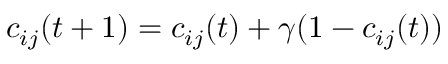Convert formula to latex. <formula><loc_0><loc_0><loc_500><loc_500>c _ { i j } ( t + 1 ) = c _ { i j } ( t ) + \gamma ( 1 - c _ { i j } ( t ) )</formula> 